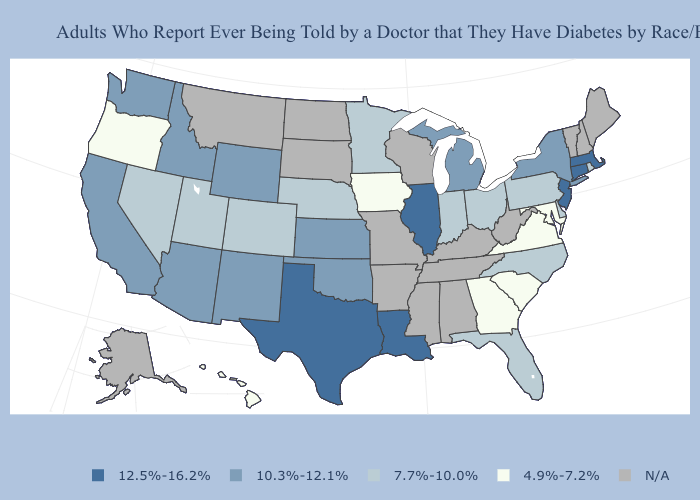Which states have the lowest value in the MidWest?
Write a very short answer. Iowa. Does Texas have the lowest value in the USA?
Keep it brief. No. What is the value of Arizona?
Concise answer only. 10.3%-12.1%. Which states have the lowest value in the USA?
Be succinct. Georgia, Hawaii, Iowa, Maryland, Oregon, South Carolina, Virginia. Does the map have missing data?
Give a very brief answer. Yes. Name the states that have a value in the range 12.5%-16.2%?
Short answer required. Connecticut, Illinois, Louisiana, Massachusetts, New Jersey, Texas. What is the value of Colorado?
Keep it brief. 7.7%-10.0%. Which states have the lowest value in the West?
Keep it brief. Hawaii, Oregon. Among the states that border Wyoming , does Nebraska have the highest value?
Write a very short answer. No. Name the states that have a value in the range 10.3%-12.1%?
Give a very brief answer. Arizona, California, Idaho, Kansas, Michigan, New Mexico, New York, Oklahoma, Washington, Wyoming. Does the map have missing data?
Keep it brief. Yes. What is the lowest value in the Northeast?
Be succinct. 7.7%-10.0%. What is the value of Oklahoma?
Quick response, please. 10.3%-12.1%. Name the states that have a value in the range N/A?
Answer briefly. Alabama, Alaska, Arkansas, Kentucky, Maine, Mississippi, Missouri, Montana, New Hampshire, North Dakota, South Dakota, Tennessee, Vermont, West Virginia, Wisconsin. 